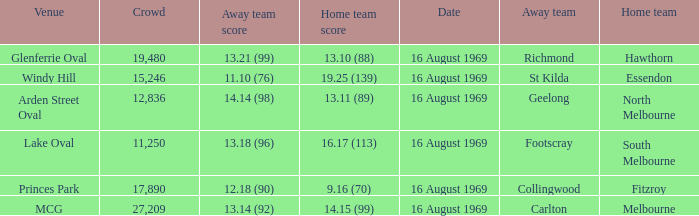What was the away team's score at Princes Park? 12.18 (90). 